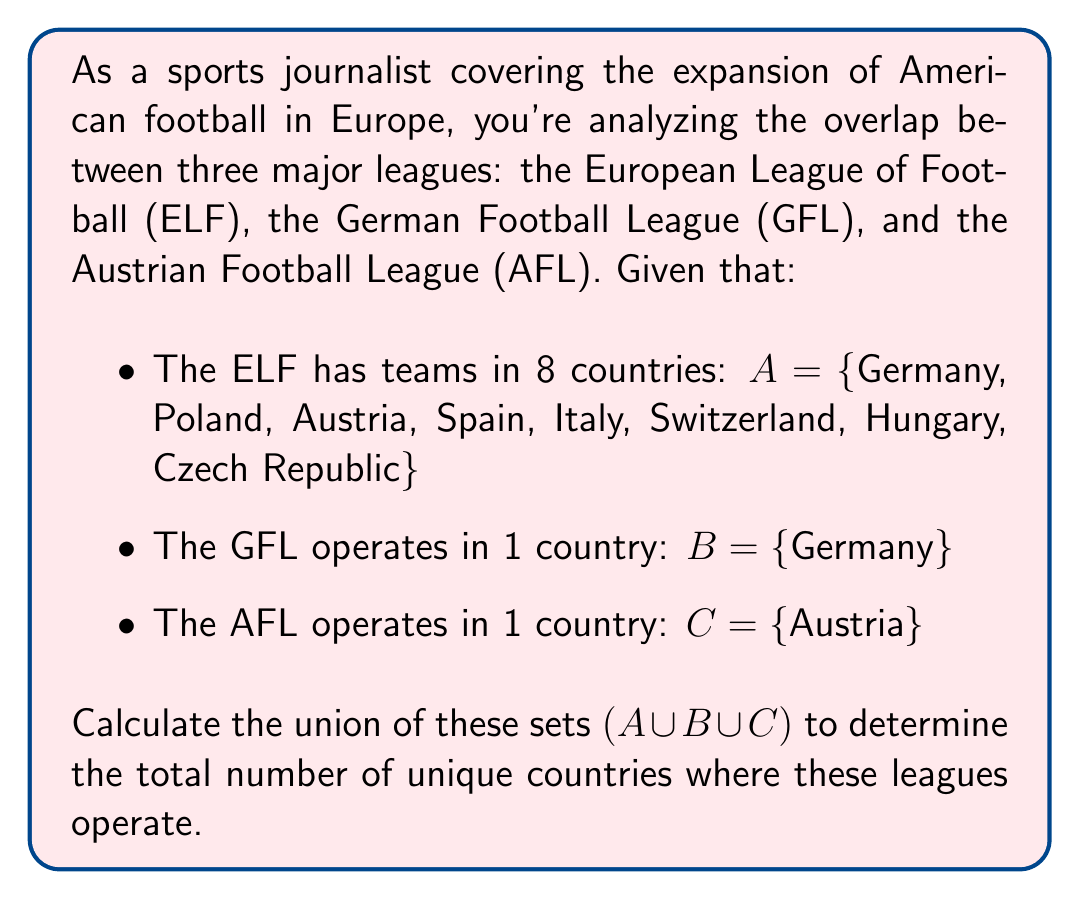Can you solve this math problem? To solve this problem, we need to find the union of sets A, B, and C. The union of sets includes all unique elements from all sets without repetition.

Let's break it down step-by-step:

1) First, let's list out all the countries from each set:
   
   $A = \{Germany, Poland, Austria, Spain, Italy, Switzerland, Hungary, Czech Republic\}$
   $B = \{Germany\}$
   $C = \{Austria\}$

2) Now, we need to combine all these countries, but we only count each country once, even if it appears in multiple sets.

3) We can see that:
   - Germany appears in both A and B
   - Austria appears in both A and C
   - All other countries in A are unique

4) Therefore, the union $A \cup B \cup C$ will include:
   - All countries from A (8 countries)
   - No additional countries from B (as Germany is already in A)
   - No additional countries from C (as Austria is already in A)

5) Thus, the union $A \cup B \cup C$ is the same as set A:

   $A \cup B \cup C = \{Germany, Poland, Austria, Spain, Italy, Switzerland, Hungary, Czech Republic\}$

6) To find the total number of unique countries, we simply count the elements in this set, which is 8.
Answer: The union of the sets is $A \cup B \cup C = \{Germany, Poland, Austria, Spain, Italy, Switzerland, Hungary, Czech Republic\}$, and the total number of unique countries where these leagues operate is 8. 